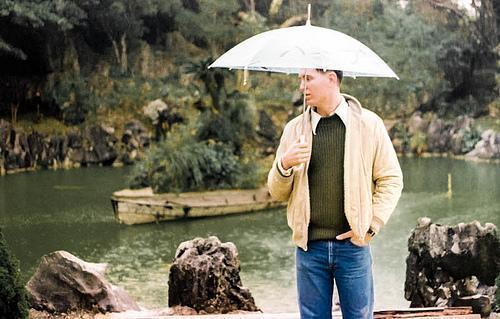How many men are there?
Give a very brief answer. 1. 